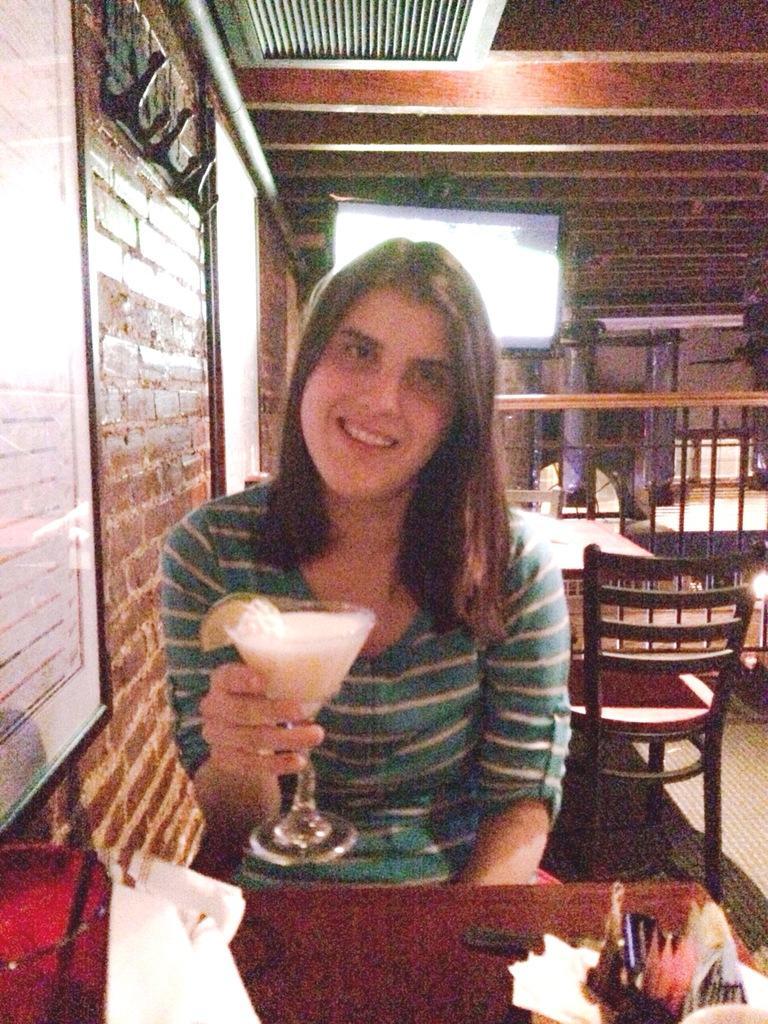How would you summarize this image in a sentence or two? in the picture there is a restaurant a woman is sitting on chair holding a glass with some food item in it sitting in front of a table. 